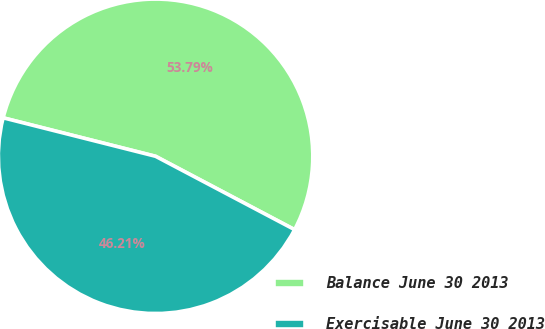Convert chart. <chart><loc_0><loc_0><loc_500><loc_500><pie_chart><fcel>Balance June 30 2013<fcel>Exercisable June 30 2013<nl><fcel>53.79%<fcel>46.21%<nl></chart> 